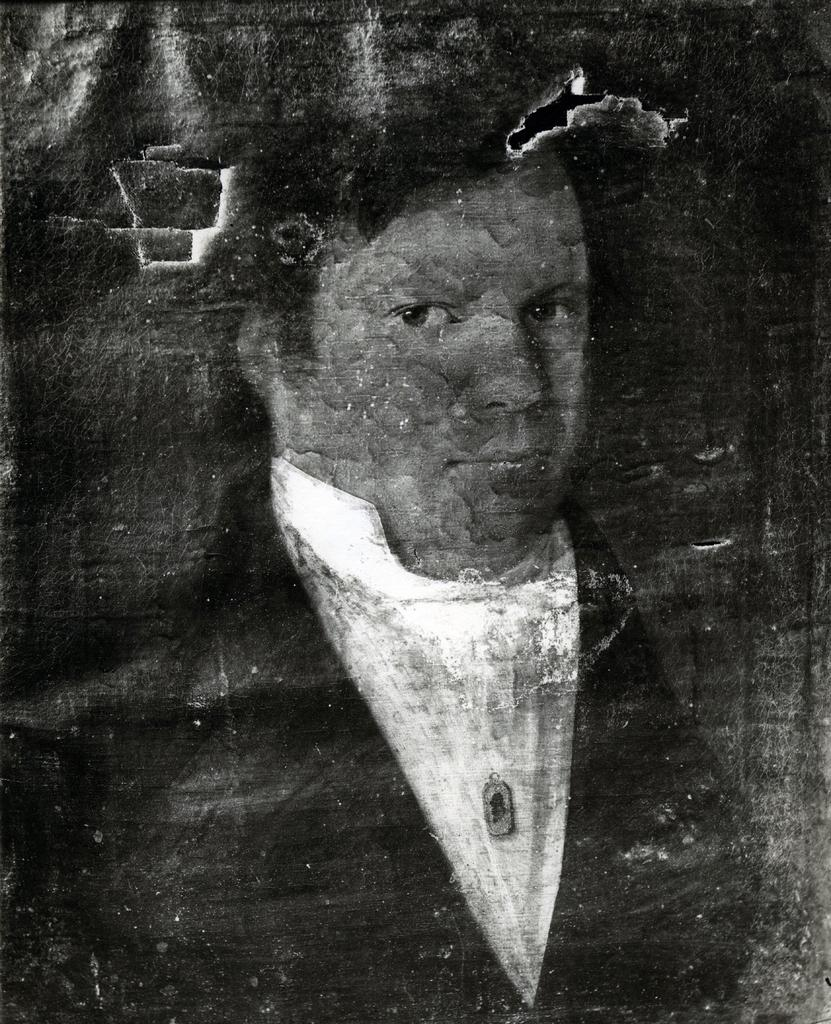What is the main subject of the image? The main subject of the image is a person's wall painting. Can you describe the lighting conditions in the image? The image may have been taken during the night, as there is no indication of daylight. What type of corn can be seen on the floor in the image? There is no corn present in the image; it only features a person's wall painting. 